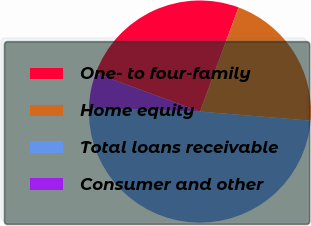Convert chart to OTSL. <chart><loc_0><loc_0><loc_500><loc_500><pie_chart><fcel>One- to four-family<fcel>Home equity<fcel>Total loans receivable<fcel>Consumer and other<nl><fcel>25.05%<fcel>20.65%<fcel>49.19%<fcel>5.11%<nl></chart> 